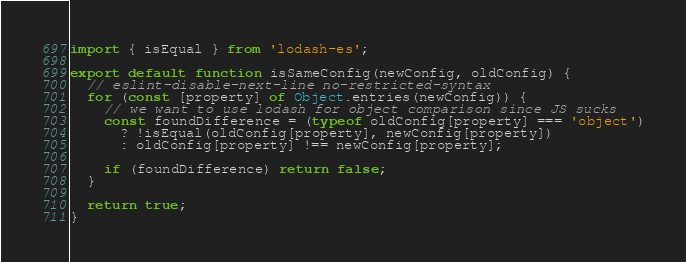<code> <loc_0><loc_0><loc_500><loc_500><_JavaScript_>import { isEqual } from 'lodash-es';

export default function isSameConfig(newConfig, oldConfig) {
  // eslint-disable-next-line no-restricted-syntax
  for (const [property] of Object.entries(newConfig)) {
    // we want to use lodash for object comparison since JS sucks
    const foundDifference = (typeof oldConfig[property] === 'object')
      ? !isEqual(oldConfig[property], newConfig[property])
      : oldConfig[property] !== newConfig[property];

    if (foundDifference) return false;
  }

  return true;
}
</code> 